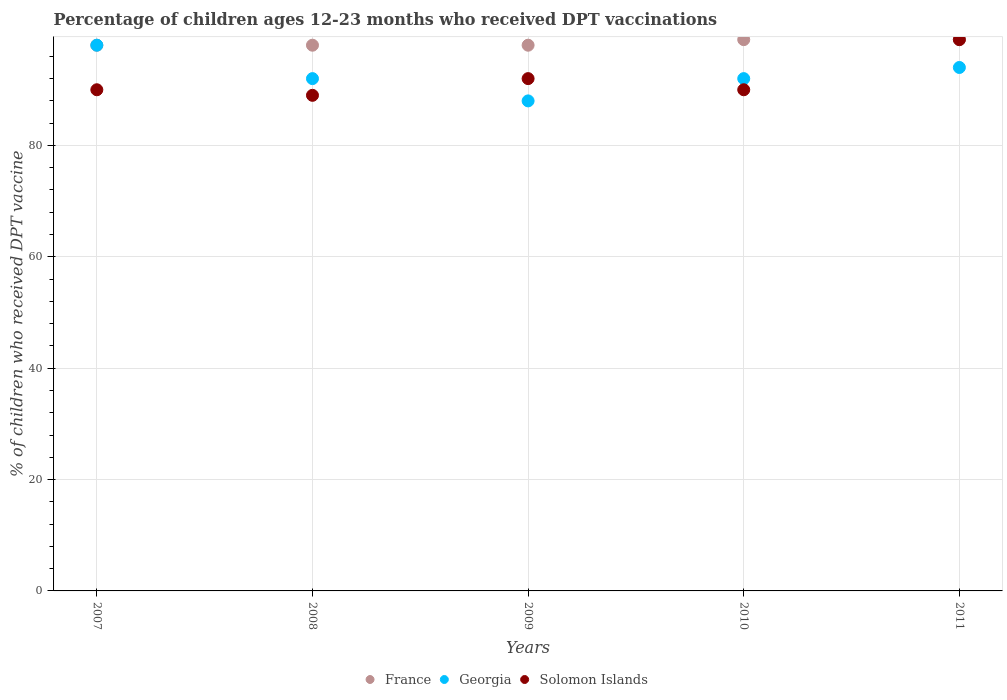How many different coloured dotlines are there?
Ensure brevity in your answer.  3. What is the percentage of children who received DPT vaccination in Georgia in 2009?
Offer a very short reply. 88. Across all years, what is the maximum percentage of children who received DPT vaccination in Solomon Islands?
Your answer should be very brief. 99. Across all years, what is the minimum percentage of children who received DPT vaccination in Solomon Islands?
Your answer should be compact. 89. In which year was the percentage of children who received DPT vaccination in France maximum?
Your response must be concise. 2010. In which year was the percentage of children who received DPT vaccination in Georgia minimum?
Provide a short and direct response. 2009. What is the total percentage of children who received DPT vaccination in Georgia in the graph?
Ensure brevity in your answer.  464. What is the difference between the percentage of children who received DPT vaccination in France in 2007 and that in 2010?
Offer a very short reply. -1. What is the average percentage of children who received DPT vaccination in France per year?
Your answer should be very brief. 98.4. In the year 2007, what is the difference between the percentage of children who received DPT vaccination in France and percentage of children who received DPT vaccination in Georgia?
Provide a short and direct response. 0. What is the ratio of the percentage of children who received DPT vaccination in Georgia in 2009 to that in 2011?
Your answer should be compact. 0.94. What is the difference between the highest and the second highest percentage of children who received DPT vaccination in Solomon Islands?
Your answer should be compact. 7. What is the difference between the highest and the lowest percentage of children who received DPT vaccination in France?
Provide a succinct answer. 1. Is the sum of the percentage of children who received DPT vaccination in Solomon Islands in 2007 and 2008 greater than the maximum percentage of children who received DPT vaccination in France across all years?
Your answer should be compact. Yes. Is it the case that in every year, the sum of the percentage of children who received DPT vaccination in Solomon Islands and percentage of children who received DPT vaccination in Georgia  is greater than the percentage of children who received DPT vaccination in France?
Provide a short and direct response. Yes. How many dotlines are there?
Your answer should be compact. 3. How many years are there in the graph?
Provide a short and direct response. 5. What is the difference between two consecutive major ticks on the Y-axis?
Your answer should be compact. 20. Are the values on the major ticks of Y-axis written in scientific E-notation?
Offer a terse response. No. Does the graph contain any zero values?
Make the answer very short. No. Does the graph contain grids?
Give a very brief answer. Yes. How many legend labels are there?
Make the answer very short. 3. How are the legend labels stacked?
Your response must be concise. Horizontal. What is the title of the graph?
Your answer should be very brief. Percentage of children ages 12-23 months who received DPT vaccinations. Does "Least developed countries" appear as one of the legend labels in the graph?
Your answer should be very brief. No. What is the label or title of the X-axis?
Give a very brief answer. Years. What is the label or title of the Y-axis?
Offer a terse response. % of children who received DPT vaccine. What is the % of children who received DPT vaccine in France in 2007?
Give a very brief answer. 98. What is the % of children who received DPT vaccine of Georgia in 2007?
Provide a succinct answer. 98. What is the % of children who received DPT vaccine in Georgia in 2008?
Offer a terse response. 92. What is the % of children who received DPT vaccine in Solomon Islands in 2008?
Offer a terse response. 89. What is the % of children who received DPT vaccine of Georgia in 2009?
Offer a very short reply. 88. What is the % of children who received DPT vaccine of Solomon Islands in 2009?
Your answer should be compact. 92. What is the % of children who received DPT vaccine in France in 2010?
Keep it short and to the point. 99. What is the % of children who received DPT vaccine in Georgia in 2010?
Give a very brief answer. 92. What is the % of children who received DPT vaccine in France in 2011?
Your answer should be compact. 99. What is the % of children who received DPT vaccine in Georgia in 2011?
Offer a very short reply. 94. Across all years, what is the maximum % of children who received DPT vaccine in France?
Keep it short and to the point. 99. Across all years, what is the maximum % of children who received DPT vaccine of Georgia?
Provide a succinct answer. 98. Across all years, what is the minimum % of children who received DPT vaccine in Georgia?
Your answer should be very brief. 88. Across all years, what is the minimum % of children who received DPT vaccine in Solomon Islands?
Make the answer very short. 89. What is the total % of children who received DPT vaccine of France in the graph?
Your response must be concise. 492. What is the total % of children who received DPT vaccine in Georgia in the graph?
Provide a succinct answer. 464. What is the total % of children who received DPT vaccine of Solomon Islands in the graph?
Give a very brief answer. 460. What is the difference between the % of children who received DPT vaccine in France in 2007 and that in 2008?
Your answer should be very brief. 0. What is the difference between the % of children who received DPT vaccine of France in 2007 and that in 2009?
Offer a very short reply. 0. What is the difference between the % of children who received DPT vaccine in Georgia in 2007 and that in 2010?
Your response must be concise. 6. What is the difference between the % of children who received DPT vaccine of Solomon Islands in 2007 and that in 2010?
Your response must be concise. 0. What is the difference between the % of children who received DPT vaccine of Solomon Islands in 2007 and that in 2011?
Offer a terse response. -9. What is the difference between the % of children who received DPT vaccine in Solomon Islands in 2008 and that in 2009?
Your answer should be very brief. -3. What is the difference between the % of children who received DPT vaccine of Solomon Islands in 2008 and that in 2011?
Your answer should be very brief. -10. What is the difference between the % of children who received DPT vaccine of France in 2010 and that in 2011?
Give a very brief answer. 0. What is the difference between the % of children who received DPT vaccine in France in 2007 and the % of children who received DPT vaccine in Georgia in 2008?
Provide a succinct answer. 6. What is the difference between the % of children who received DPT vaccine of Georgia in 2007 and the % of children who received DPT vaccine of Solomon Islands in 2008?
Provide a succinct answer. 9. What is the difference between the % of children who received DPT vaccine in Georgia in 2007 and the % of children who received DPT vaccine in Solomon Islands in 2009?
Provide a short and direct response. 6. What is the difference between the % of children who received DPT vaccine of France in 2007 and the % of children who received DPT vaccine of Solomon Islands in 2010?
Make the answer very short. 8. What is the difference between the % of children who received DPT vaccine of France in 2007 and the % of children who received DPT vaccine of Georgia in 2011?
Provide a short and direct response. 4. What is the difference between the % of children who received DPT vaccine of France in 2007 and the % of children who received DPT vaccine of Solomon Islands in 2011?
Provide a succinct answer. -1. What is the difference between the % of children who received DPT vaccine of France in 2008 and the % of children who received DPT vaccine of Solomon Islands in 2009?
Provide a succinct answer. 6. What is the difference between the % of children who received DPT vaccine in France in 2008 and the % of children who received DPT vaccine in Georgia in 2010?
Offer a terse response. 6. What is the difference between the % of children who received DPT vaccine in France in 2008 and the % of children who received DPT vaccine in Solomon Islands in 2010?
Provide a succinct answer. 8. What is the difference between the % of children who received DPT vaccine in Georgia in 2008 and the % of children who received DPT vaccine in Solomon Islands in 2010?
Offer a very short reply. 2. What is the difference between the % of children who received DPT vaccine in Georgia in 2008 and the % of children who received DPT vaccine in Solomon Islands in 2011?
Provide a succinct answer. -7. What is the difference between the % of children who received DPT vaccine of France in 2009 and the % of children who received DPT vaccine of Georgia in 2010?
Your answer should be very brief. 6. What is the difference between the % of children who received DPT vaccine in France in 2009 and the % of children who received DPT vaccine in Solomon Islands in 2011?
Provide a succinct answer. -1. What is the difference between the % of children who received DPT vaccine in France in 2010 and the % of children who received DPT vaccine in Solomon Islands in 2011?
Ensure brevity in your answer.  0. What is the average % of children who received DPT vaccine of France per year?
Ensure brevity in your answer.  98.4. What is the average % of children who received DPT vaccine of Georgia per year?
Give a very brief answer. 92.8. What is the average % of children who received DPT vaccine in Solomon Islands per year?
Offer a very short reply. 92. In the year 2007, what is the difference between the % of children who received DPT vaccine in France and % of children who received DPT vaccine in Georgia?
Make the answer very short. 0. In the year 2007, what is the difference between the % of children who received DPT vaccine of France and % of children who received DPT vaccine of Solomon Islands?
Make the answer very short. 8. In the year 2007, what is the difference between the % of children who received DPT vaccine in Georgia and % of children who received DPT vaccine in Solomon Islands?
Offer a terse response. 8. In the year 2010, what is the difference between the % of children who received DPT vaccine of France and % of children who received DPT vaccine of Georgia?
Your answer should be very brief. 7. In the year 2010, what is the difference between the % of children who received DPT vaccine of Georgia and % of children who received DPT vaccine of Solomon Islands?
Give a very brief answer. 2. In the year 2011, what is the difference between the % of children who received DPT vaccine in France and % of children who received DPT vaccine in Solomon Islands?
Keep it short and to the point. 0. What is the ratio of the % of children who received DPT vaccine of Georgia in 2007 to that in 2008?
Keep it short and to the point. 1.07. What is the ratio of the % of children who received DPT vaccine of Solomon Islands in 2007 to that in 2008?
Give a very brief answer. 1.01. What is the ratio of the % of children who received DPT vaccine in Georgia in 2007 to that in 2009?
Provide a short and direct response. 1.11. What is the ratio of the % of children who received DPT vaccine in Solomon Islands in 2007 to that in 2009?
Make the answer very short. 0.98. What is the ratio of the % of children who received DPT vaccine in Georgia in 2007 to that in 2010?
Offer a terse response. 1.07. What is the ratio of the % of children who received DPT vaccine of Solomon Islands in 2007 to that in 2010?
Provide a succinct answer. 1. What is the ratio of the % of children who received DPT vaccine of France in 2007 to that in 2011?
Offer a terse response. 0.99. What is the ratio of the % of children who received DPT vaccine of Georgia in 2007 to that in 2011?
Your answer should be compact. 1.04. What is the ratio of the % of children who received DPT vaccine in France in 2008 to that in 2009?
Offer a very short reply. 1. What is the ratio of the % of children who received DPT vaccine in Georgia in 2008 to that in 2009?
Ensure brevity in your answer.  1.05. What is the ratio of the % of children who received DPT vaccine of Solomon Islands in 2008 to that in 2009?
Your response must be concise. 0.97. What is the ratio of the % of children who received DPT vaccine in Solomon Islands in 2008 to that in 2010?
Provide a short and direct response. 0.99. What is the ratio of the % of children who received DPT vaccine in Georgia in 2008 to that in 2011?
Your response must be concise. 0.98. What is the ratio of the % of children who received DPT vaccine of Solomon Islands in 2008 to that in 2011?
Provide a succinct answer. 0.9. What is the ratio of the % of children who received DPT vaccine of France in 2009 to that in 2010?
Your response must be concise. 0.99. What is the ratio of the % of children who received DPT vaccine of Georgia in 2009 to that in 2010?
Give a very brief answer. 0.96. What is the ratio of the % of children who received DPT vaccine of Solomon Islands in 2009 to that in 2010?
Keep it short and to the point. 1.02. What is the ratio of the % of children who received DPT vaccine of France in 2009 to that in 2011?
Provide a succinct answer. 0.99. What is the ratio of the % of children who received DPT vaccine of Georgia in 2009 to that in 2011?
Give a very brief answer. 0.94. What is the ratio of the % of children who received DPT vaccine of Solomon Islands in 2009 to that in 2011?
Give a very brief answer. 0.93. What is the ratio of the % of children who received DPT vaccine of France in 2010 to that in 2011?
Make the answer very short. 1. What is the ratio of the % of children who received DPT vaccine in Georgia in 2010 to that in 2011?
Make the answer very short. 0.98. What is the difference between the highest and the second highest % of children who received DPT vaccine of France?
Your answer should be compact. 0. What is the difference between the highest and the second highest % of children who received DPT vaccine of Georgia?
Make the answer very short. 4. 